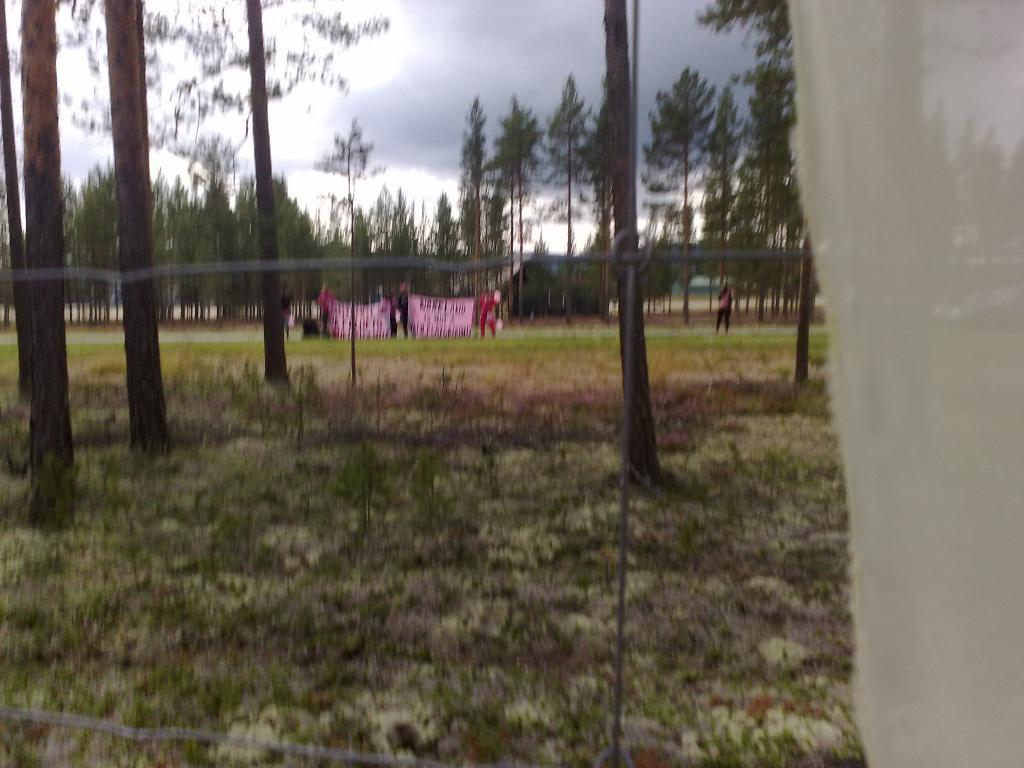What type of vegetation can be seen in the image? There is grass, plants, and trees in the image. Are there any people visible in the image? Yes, there are people in the background of the image. What is present in the background along with the people? There is a banner and trees in the background. What can be seen in the sky in the background? The sky is visible in the background with clouds. How many eyes can be seen on the celery in the image? There is no celery present in the image, and therefore no eyes can be observed on it. Is there a horse visible in the image? There is no horse present in the image. 